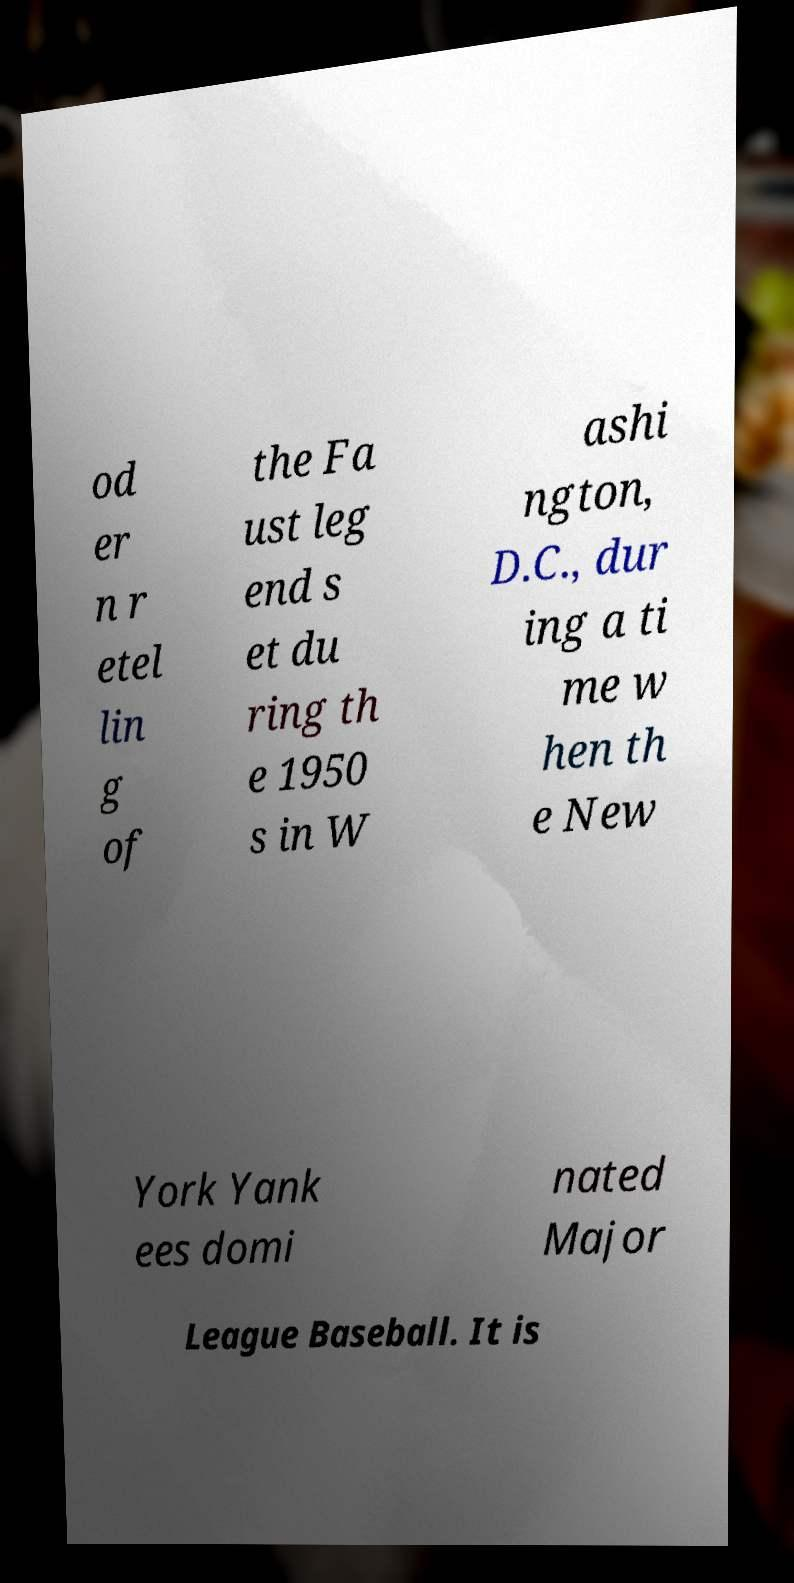Please identify and transcribe the text found in this image. od er n r etel lin g of the Fa ust leg end s et du ring th e 1950 s in W ashi ngton, D.C., dur ing a ti me w hen th e New York Yank ees domi nated Major League Baseball. It is 